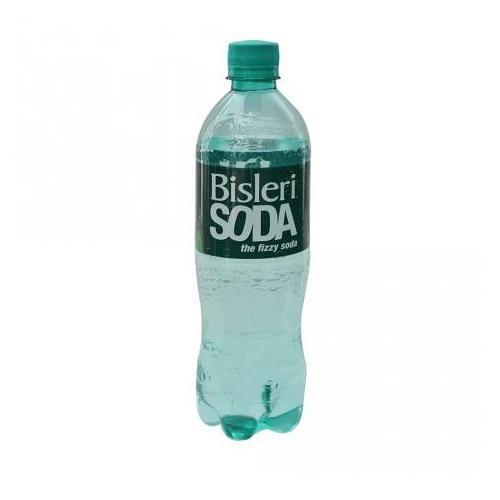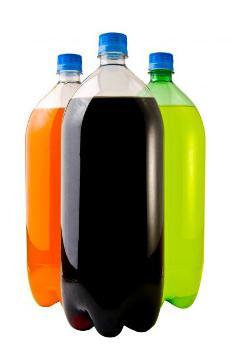The first image is the image on the left, the second image is the image on the right. Considering the images on both sides, is "One of the images shows at least one bottle of Coca-Cola." valid? Answer yes or no. No. The first image is the image on the left, the second image is the image on the right. For the images shown, is this caption "There is one bottle in one of the images, and three in the other." true? Answer yes or no. Yes. 